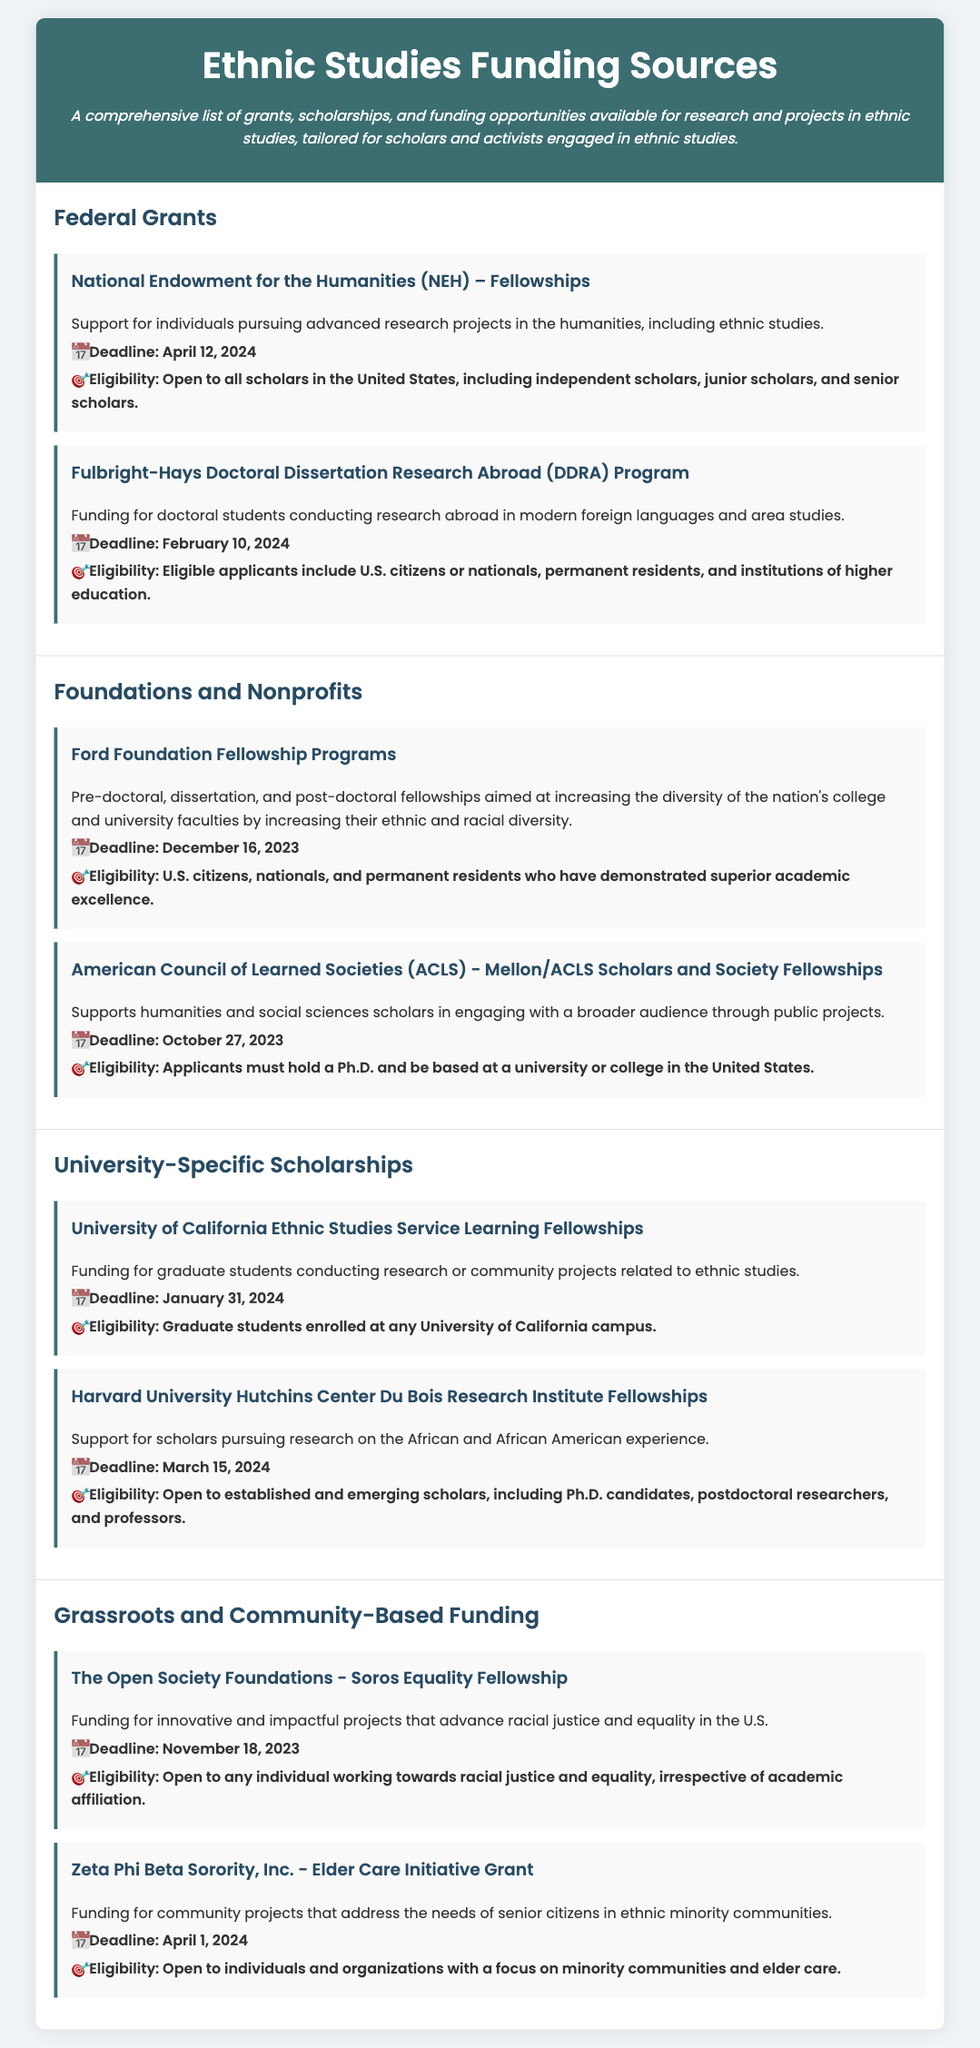what is the deadline for the NEH Fellowships? The deadline for the NEH Fellowships is explicitly stated in the document.
Answer: April 12, 2024 who is eligible for the Ford Foundation Fellowship Programs? The eligibility criteria listed in the document specifies who can apply for the Ford Foundation Fellowship Programs.
Answer: U.S. citizens, nationals, and permanent residents who have demonstrated superior academic excellence what type of funding does the Fulbright-Hays DDRA Program provide? The document mentions the nature of the funding provided under this program.
Answer: Funding for doctoral students conducting research abroad what is the common theme of the funding provided by The Open Society Foundations? The document describes the focus of The Open Society Foundations funding opportunity.
Answer: Racial justice and equality how many funding opportunities are listed in the Foundations and Nonprofits section? This can be determined by counting the funding items in the Foundations and Nonprofits section of the document.
Answer: 2 what type of projects does the Zeta Phi Beta Sorority, Inc. grant address? The document specifies the focus of the Zeta Phi Beta Sorority, Inc. grant regarding community projects.
Answer: Elder care which fellowship has a deadline of October 27, 2023? The document lists funding opportunities along with their deadlines; the deadline matches one specific fellowship.
Answer: ACLS - Mellon/ACLS Scholars and Society Fellowships who can apply for the University of California Ethnic Studies Service Learning Fellowships? The document indicates specific eligibility for the University of California fellowship.
Answer: Graduate students enrolled at any University of California campus 